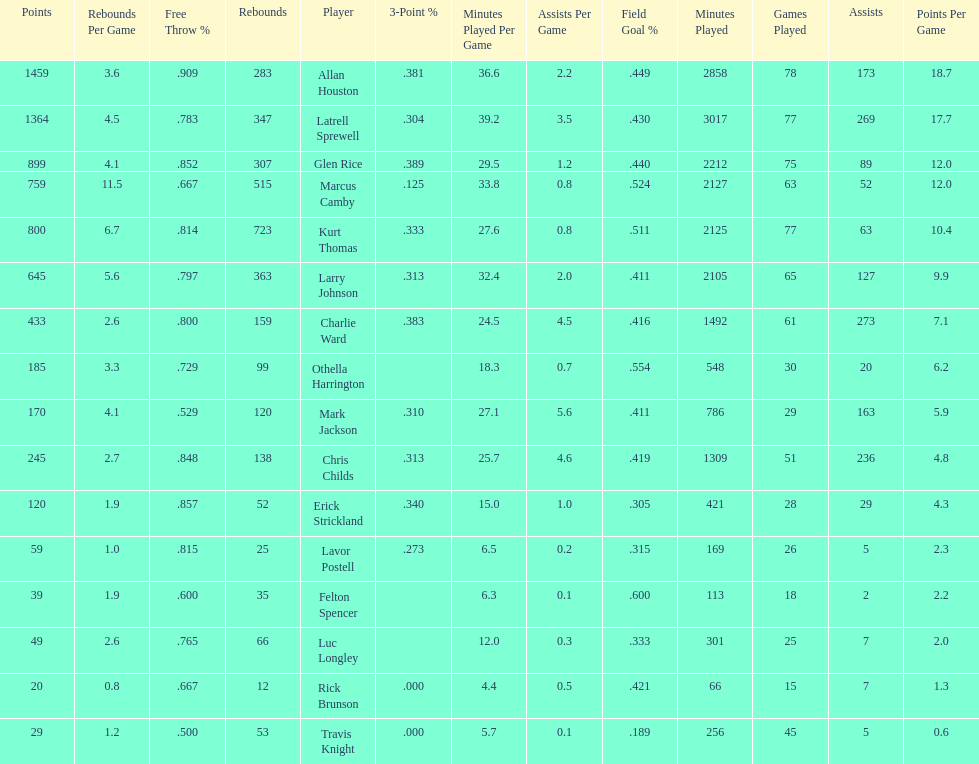How many players had a field goal percentage greater than .500? 4. 